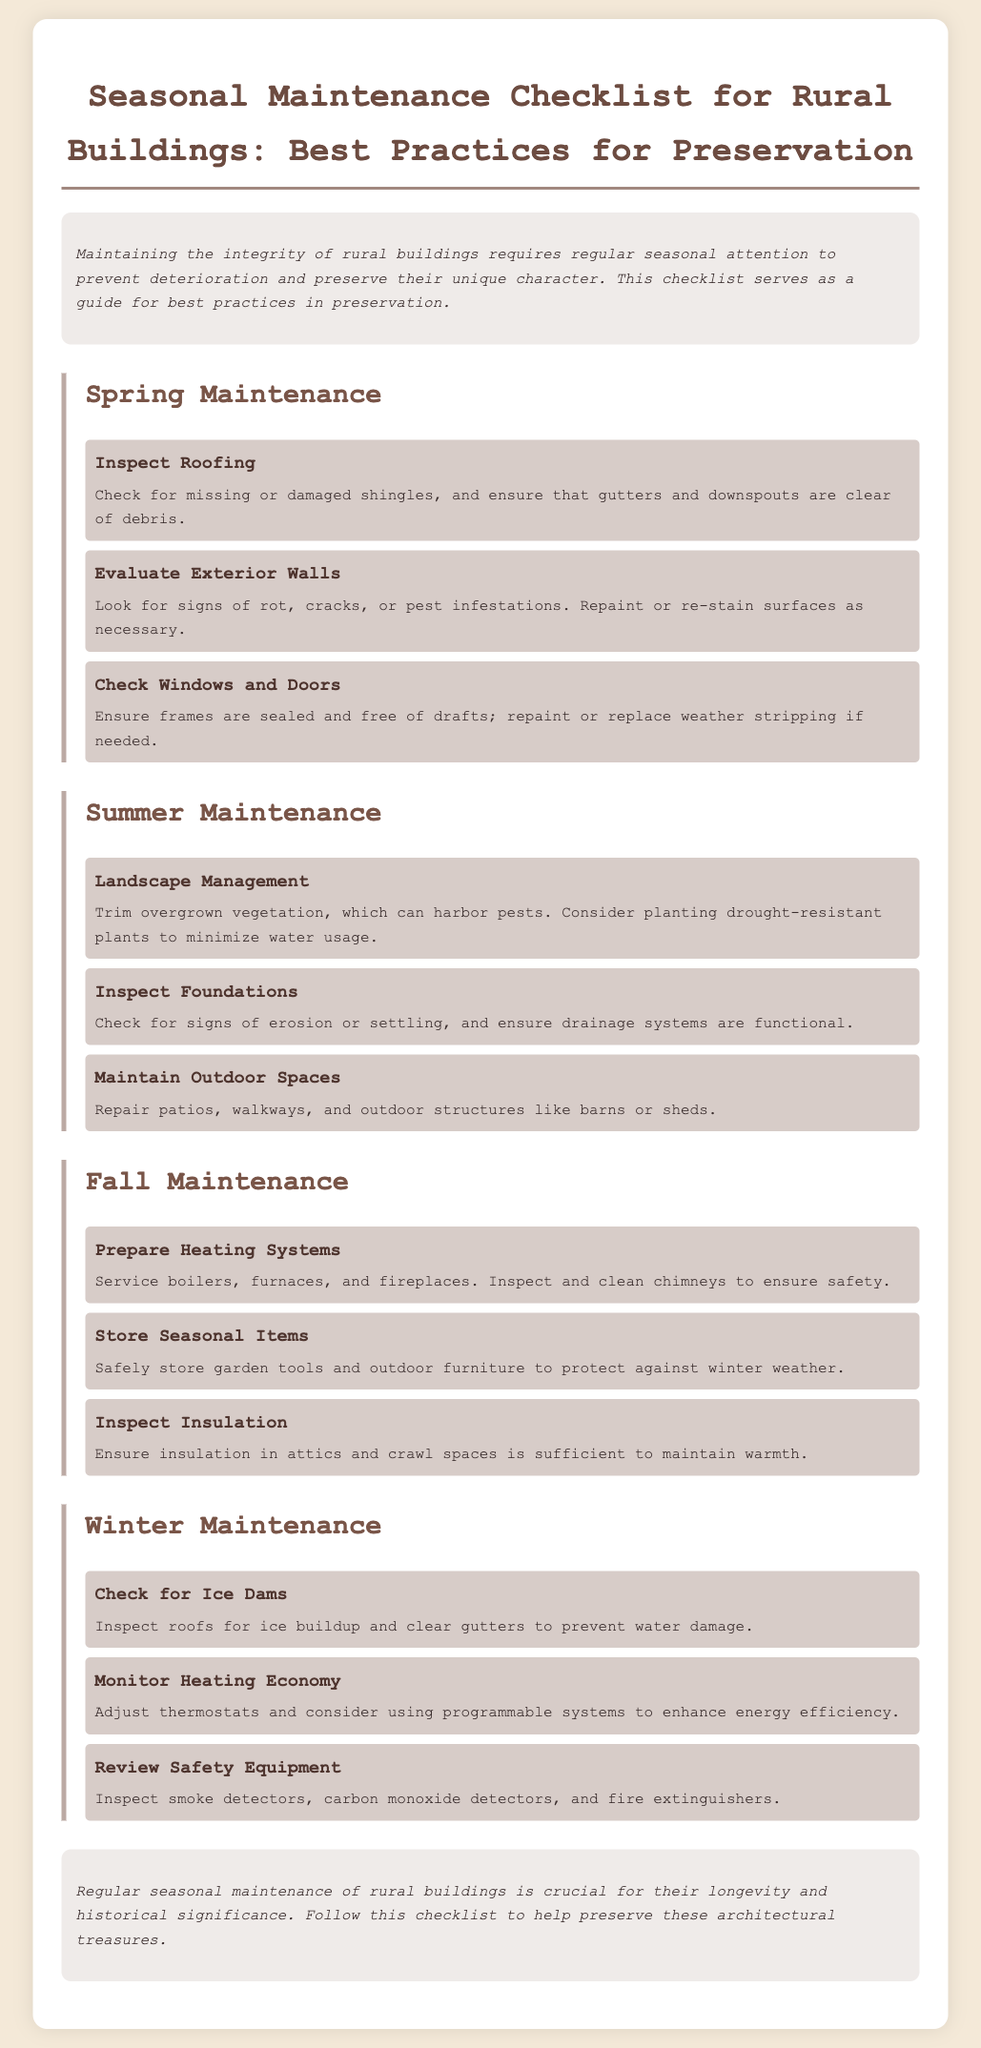what are the main seasons covered in the checklist? The checklist includes spring, summer, fall, and winter as the main seasons for maintenance.
Answer: spring, summer, fall, winter what is the purpose of the seasonal maintenance checklist? The purpose is to guide regular seasonal attention to prevent deterioration and preserve the unique character of rural buildings.
Answer: preserve rural buildings how many tasks are listed under summer maintenance? There are three tasks listed under summer maintenance focusing on landscape management, foundation inspection, and outdoor space maintenance.
Answer: three what should be inspected in the fall maintenance section? In the fall maintenance section, heating systems, insulation, and seasonal item storage should be inspected.
Answer: heating systems, insulation, seasonal item storage what task is performed in winter maintenance to prevent water damage? The task performed is to check for ice dams to prevent water damage.
Answer: check for ice dams which exterior feature needs evaluation in spring? The exterior walls need evaluation for signs of rot, cracks, or pest infestations in spring.
Answer: exterior walls what is advised to be planted in summer for water conservation? The checklist advises planting drought-resistant plants to minimize water usage during summer.
Answer: drought-resistant plants how is the checklist summarized at the end? The conclusion emphasizes the importance of regular seasonal maintenance for the longevity and historical significance of rural buildings.
Answer: importance of regular maintenance 